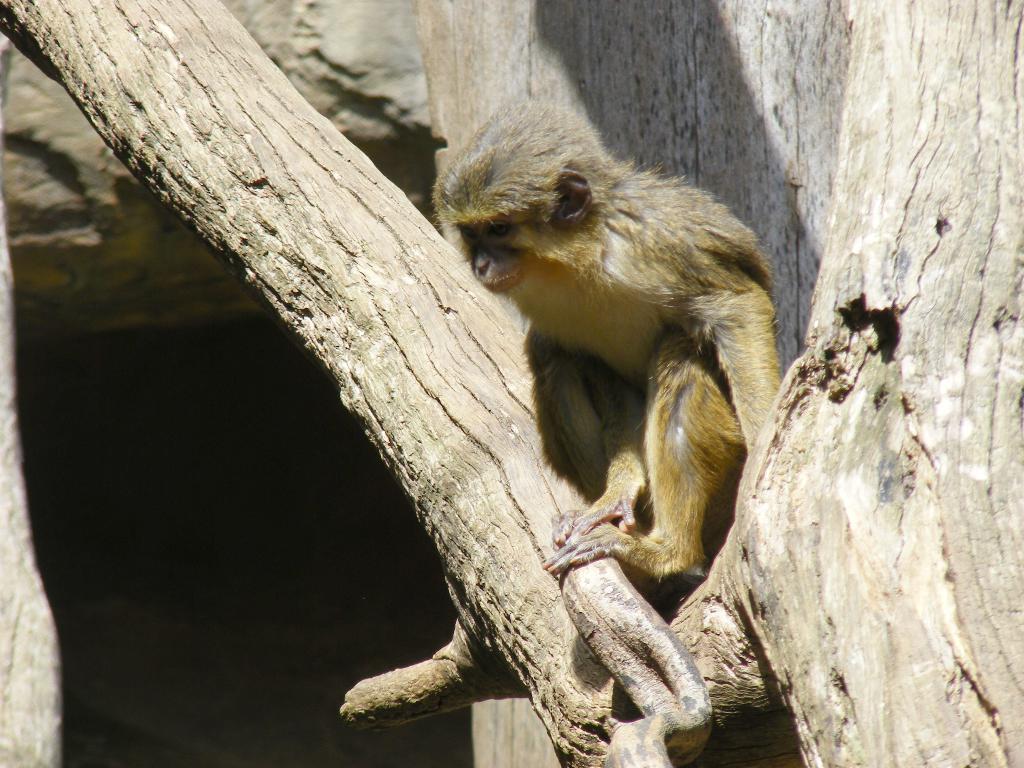How would you summarize this image in a sentence or two? This picture shows a monkey on the tree and it is brown in color. 